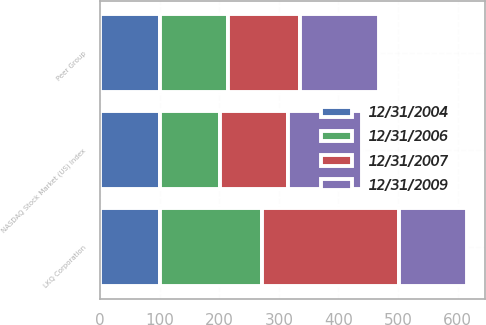Convert chart. <chart><loc_0><loc_0><loc_500><loc_500><stacked_bar_chart><ecel><fcel>LKQ Corporation<fcel>NASDAQ Stock Market (US) Index<fcel>Peer Group<nl><fcel>12/31/2004<fcel>100<fcel>100<fcel>100<nl><fcel>12/31/2006<fcel>172<fcel>102<fcel>115<nl><fcel>12/31/2007<fcel>229<fcel>113<fcel>121<nl><fcel>12/31/2009<fcel>115<fcel>125<fcel>132<nl></chart> 